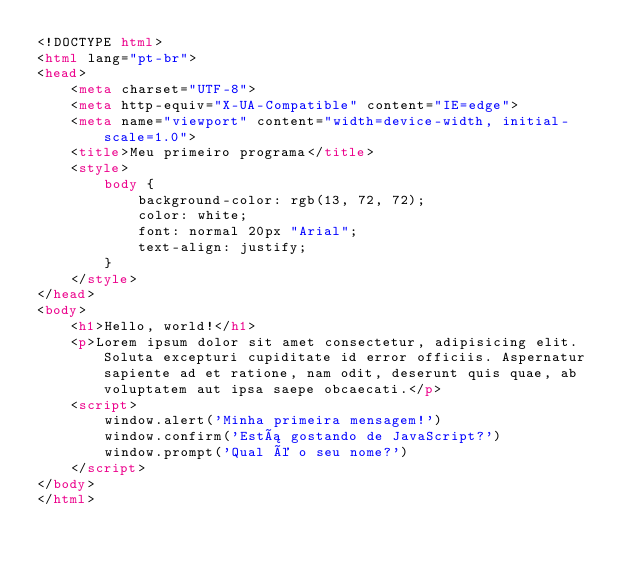<code> <loc_0><loc_0><loc_500><loc_500><_HTML_><!DOCTYPE html>
<html lang="pt-br">
<head>
    <meta charset="UTF-8">
    <meta http-equiv="X-UA-Compatible" content="IE=edge">
    <meta name="viewport" content="width=device-width, initial-scale=1.0">
    <title>Meu primeiro programa</title>
    <style>
        body {
            background-color: rgb(13, 72, 72);
            color: white;
            font: normal 20px "Arial";
            text-align: justify;
        }
    </style>
</head>
<body>
    <h1>Hello, world!</h1>
    <p>Lorem ipsum dolor sit amet consectetur, adipisicing elit. Soluta excepturi cupiditate id error officiis. Aspernatur sapiente ad et ratione, nam odit, deserunt quis quae, ab voluptatem aut ipsa saepe obcaecati.</p>
    <script>
        window.alert('Minha primeira mensagem!')
        window.confirm('Está gostando de JavaScript?')
        window.prompt('Qual é o seu nome?')
    </script>
</body>
</html></code> 